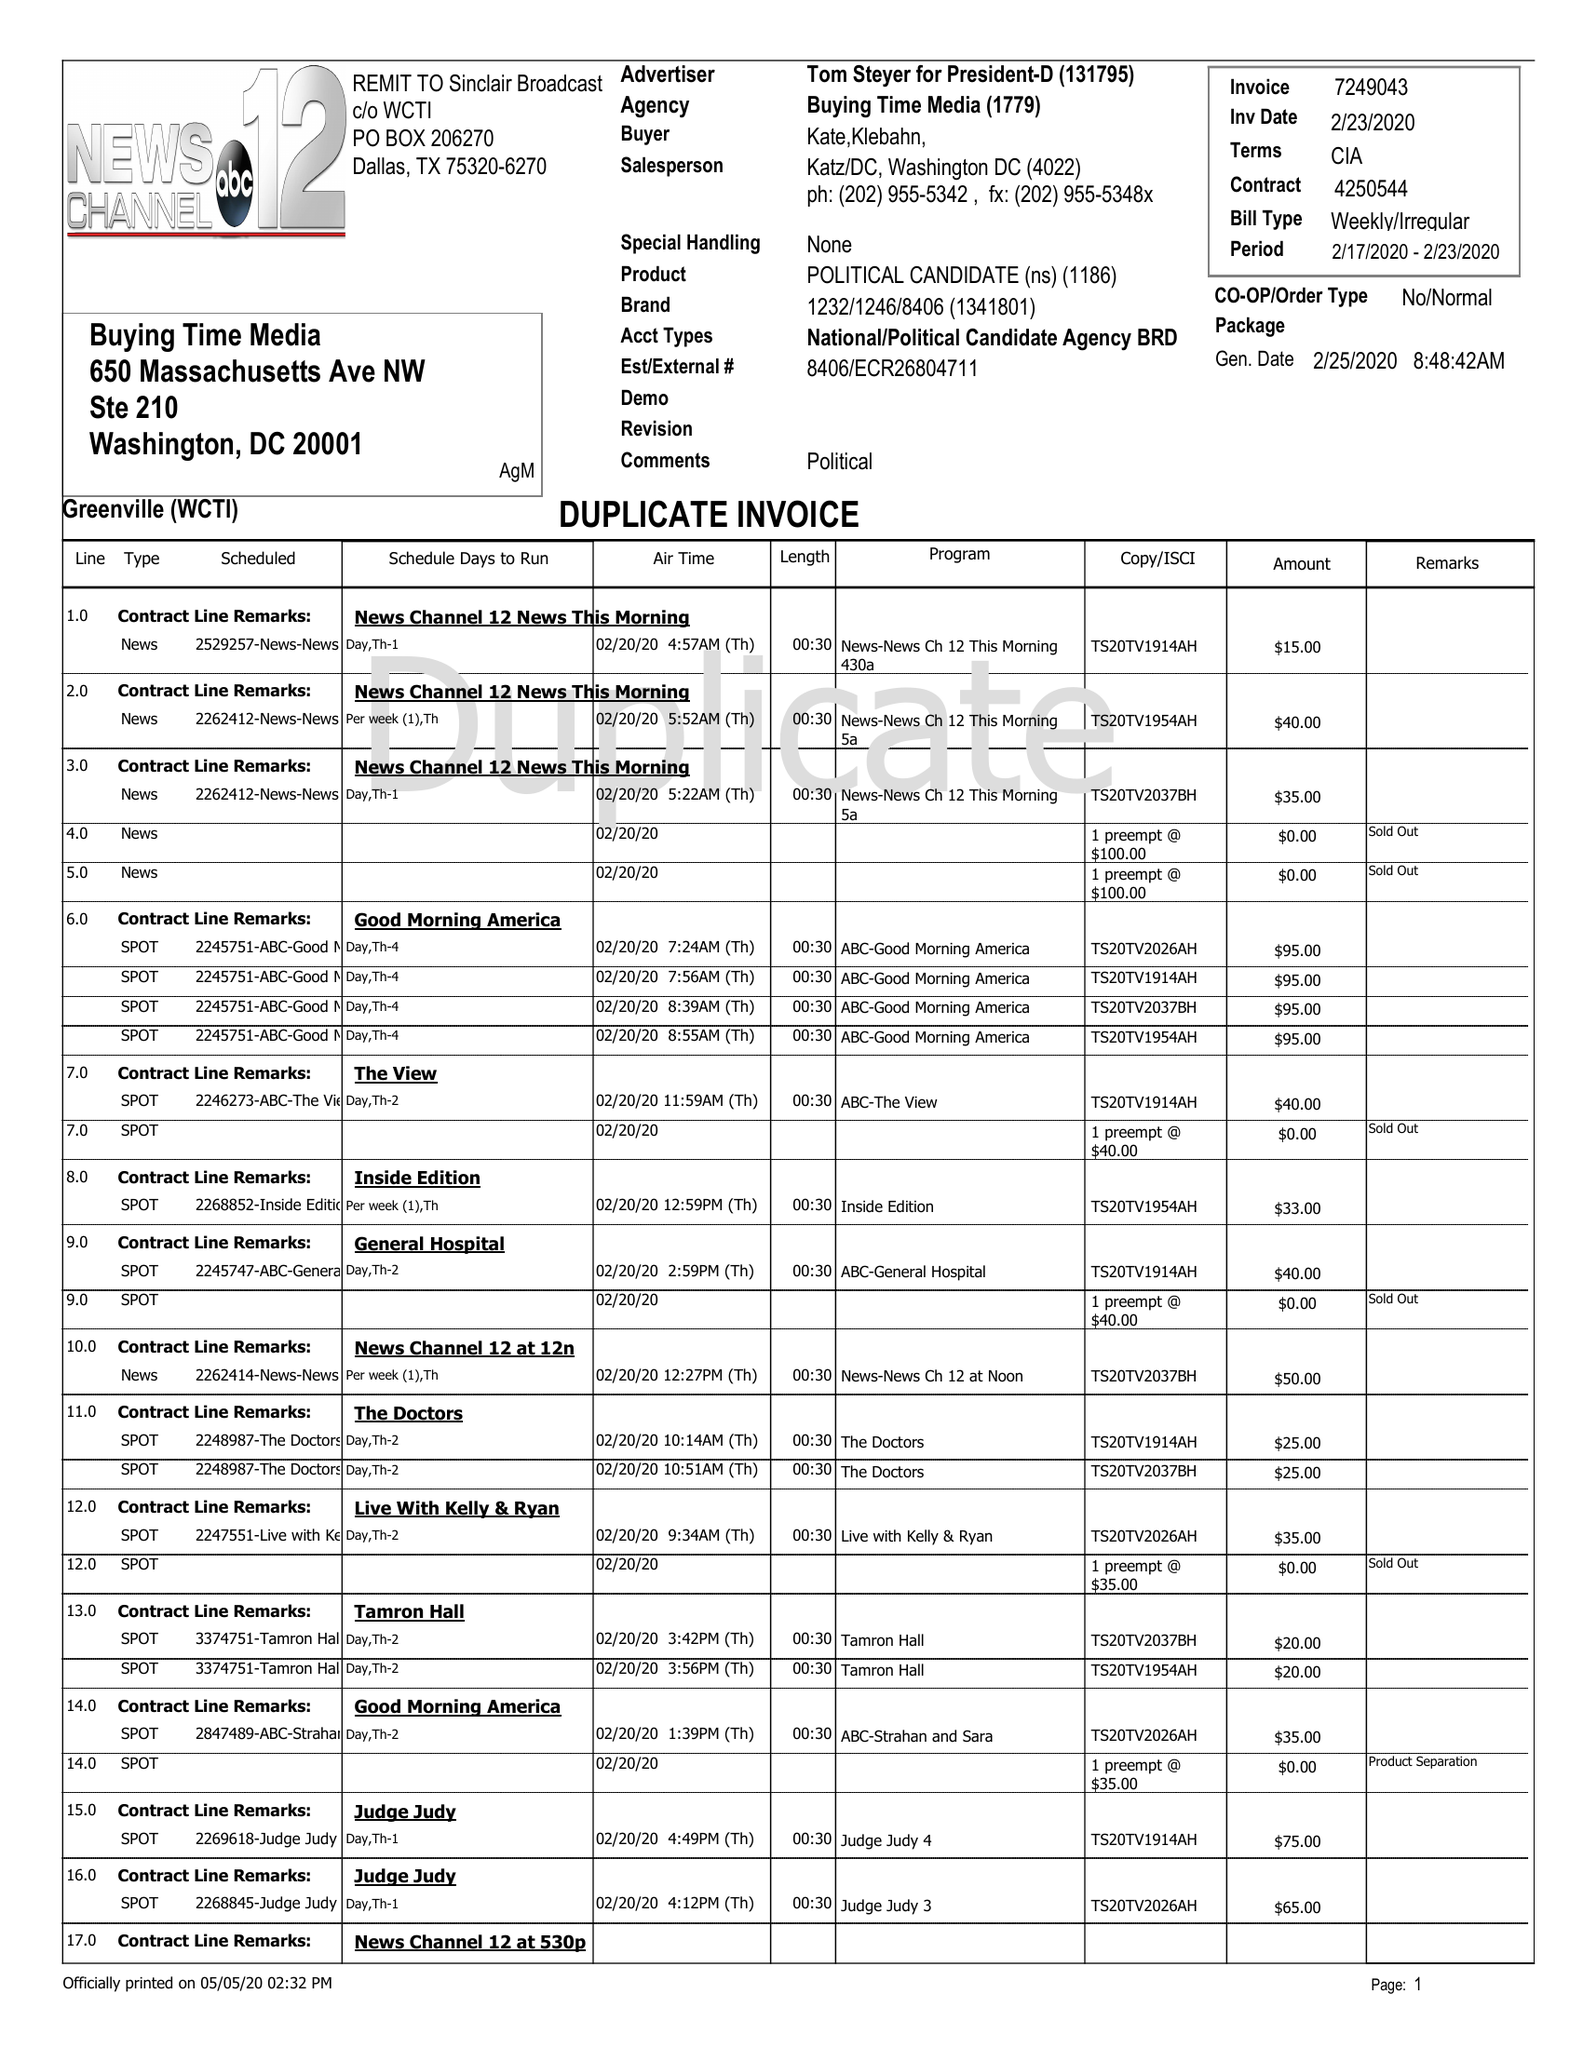What is the value for the advertiser?
Answer the question using a single word or phrase. TOM STEYER FOR PRESIDENT 